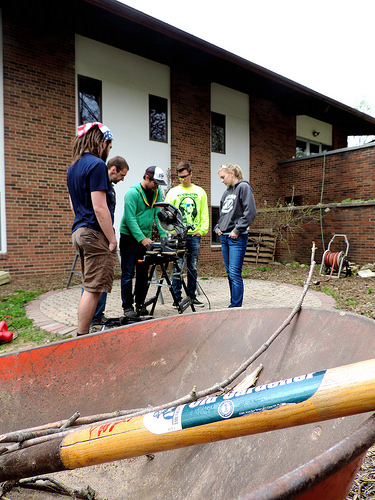<image>
Is there a man behind the wheel barrow? Yes. From this viewpoint, the man is positioned behind the wheel barrow, with the wheel barrow partially or fully occluding the man. 